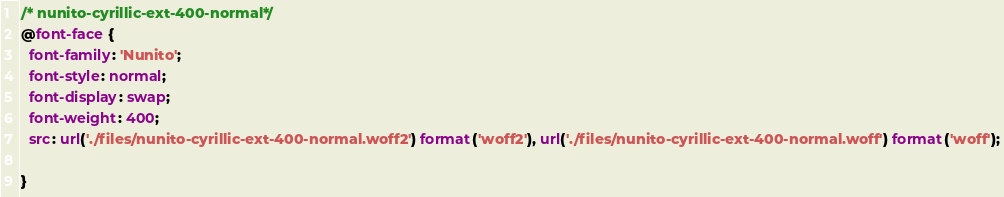Convert code to text. <code><loc_0><loc_0><loc_500><loc_500><_CSS_>/* nunito-cyrillic-ext-400-normal*/
@font-face {
  font-family: 'Nunito';
  font-style: normal;
  font-display: swap;
  font-weight: 400;
  src: url('./files/nunito-cyrillic-ext-400-normal.woff2') format('woff2'), url('./files/nunito-cyrillic-ext-400-normal.woff') format('woff');
  
}
</code> 